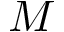<formula> <loc_0><loc_0><loc_500><loc_500>M</formula> 